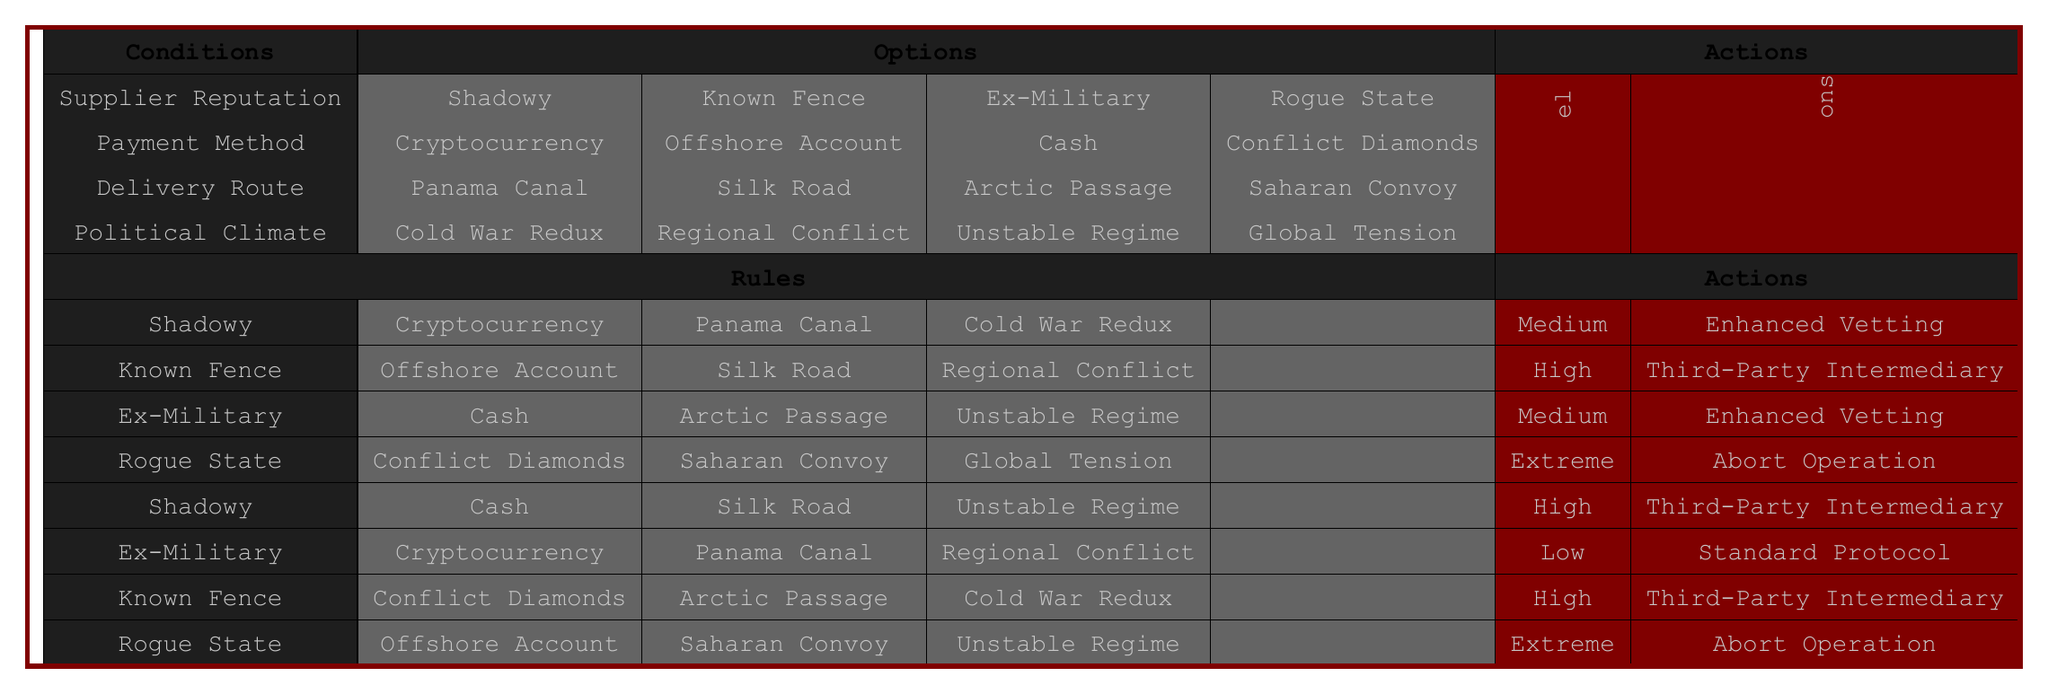What is the risk level for a known fence using an offshore account in a regional conflict? The table states that for the conditions "Known Fence", "Offshore Account", and "Regional Conflict", the corresponding risk level is "High".
Answer: High What precautions are recommended for a rogue state using conflict diamonds with a saharan convoy in a global tension scenario? According to the table, for the conditions "Rogue State", "Conflict Diamonds", "Saharan Convoy", and "Global Tension", the recommended precaution is to "Abort Operation".
Answer: Abort Operation How many unique payment methods have a high-risk level associated with them? There are three unique payment methods leading to a high-risk level: "Offshore Account" from the "Known Fence" case, "Cash" from the "Shadowy" case, and "Conflict Diamonds" from the "Known Fence" case again. Thus, there are three unique payment methods.
Answer: Three Is there any condition where the risk level is classified as low? The table indicates that the only condition that results in a low-risk level is "Ex-Military" with "Cryptocurrency", "Panama Canal", and "Regional Conflict". Therefore, the answer is yes.
Answer: Yes What are the recommended precautions for a shadowy supplier using cash through the silk road in an unstable regime? The table shows that for the conditions "Shadowy", "Cash", "Silk Road", and "Unstable Regime", the recommended precaution is "Third-Party Intermediary".
Answer: Third-Party Intermediary What is the risk level for an ex-military supplier using cash with an arctic passage in an unstable regime? The table indicates that the conditions "Ex-Military", "Cash", "Arctic Passage", and "Unstable Regime" lead to a risk level of "Medium".
Answer: Medium Are there more extreme risk levels associated with rogue states compared to known fences? The table lists "Extreme" risk levels for both "Rogue State" conditions, while "Known Fence" only has high-risk levels. Therefore, the extreme occurrences do not exceed those of known fences.
Answer: No What is the overall risk level if the supplier is ex-military, the payment method is cryptocurrency, the route is the Panama Canal, and the political climate is a regional conflict? According to the conditions in the table, "Ex-Military", "Cryptocurrency", "Panama Canal", and "Regional Conflict" correspond to a risk level of "Low".
Answer: Low What is the total number of precautions recommended for "Medium" risk levels? There are two occurrences where the risk level is "Medium" in the table: one with "Enhanced Vetting" and another with "Enhanced Vetting", for a total of one unique precaution.
Answer: One 